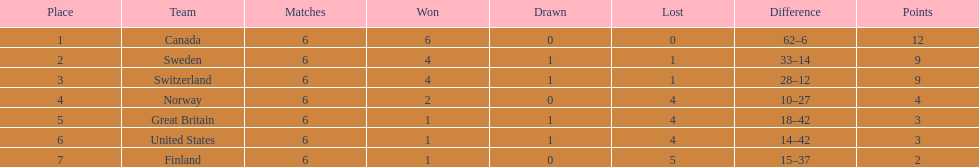What is the count of teams with 6 match wins? 1. 